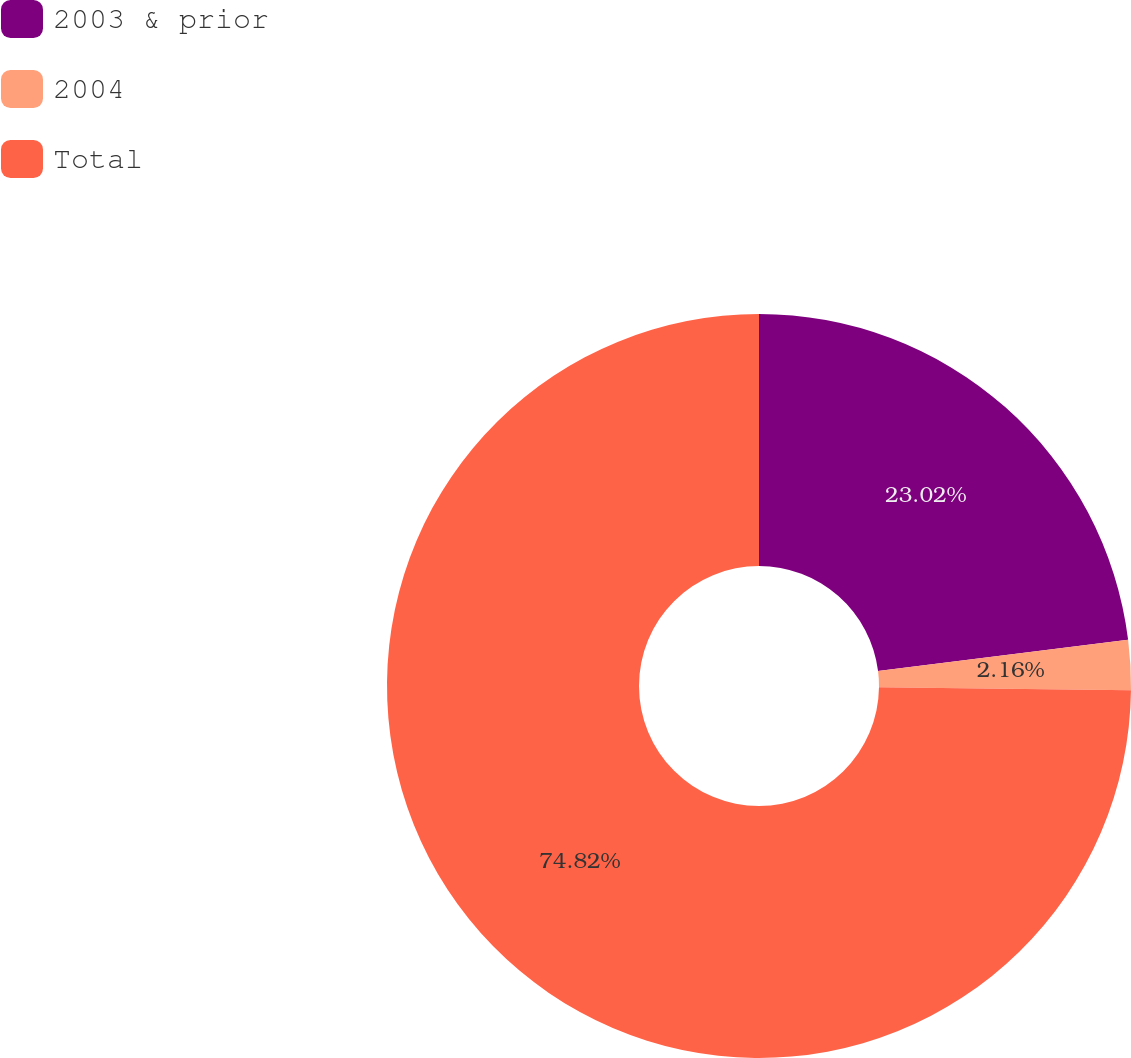<chart> <loc_0><loc_0><loc_500><loc_500><pie_chart><fcel>2003 & prior<fcel>2004<fcel>Total<nl><fcel>23.02%<fcel>2.16%<fcel>74.82%<nl></chart> 